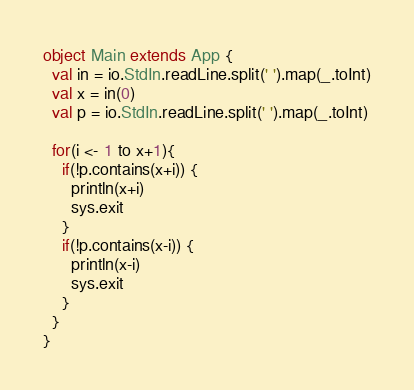Convert code to text. <code><loc_0><loc_0><loc_500><loc_500><_Scala_>object Main extends App {
  val in = io.StdIn.readLine.split(' ').map(_.toInt)
  val x = in(0)
  val p = io.StdIn.readLine.split(' ').map(_.toInt)

  for(i <- 1 to x+1){
    if(!p.contains(x+i)) {
      println(x+i)
      sys.exit
    }
    if(!p.contains(x-i)) {
      println(x-i)
      sys.exit
    }  
  }
}</code> 